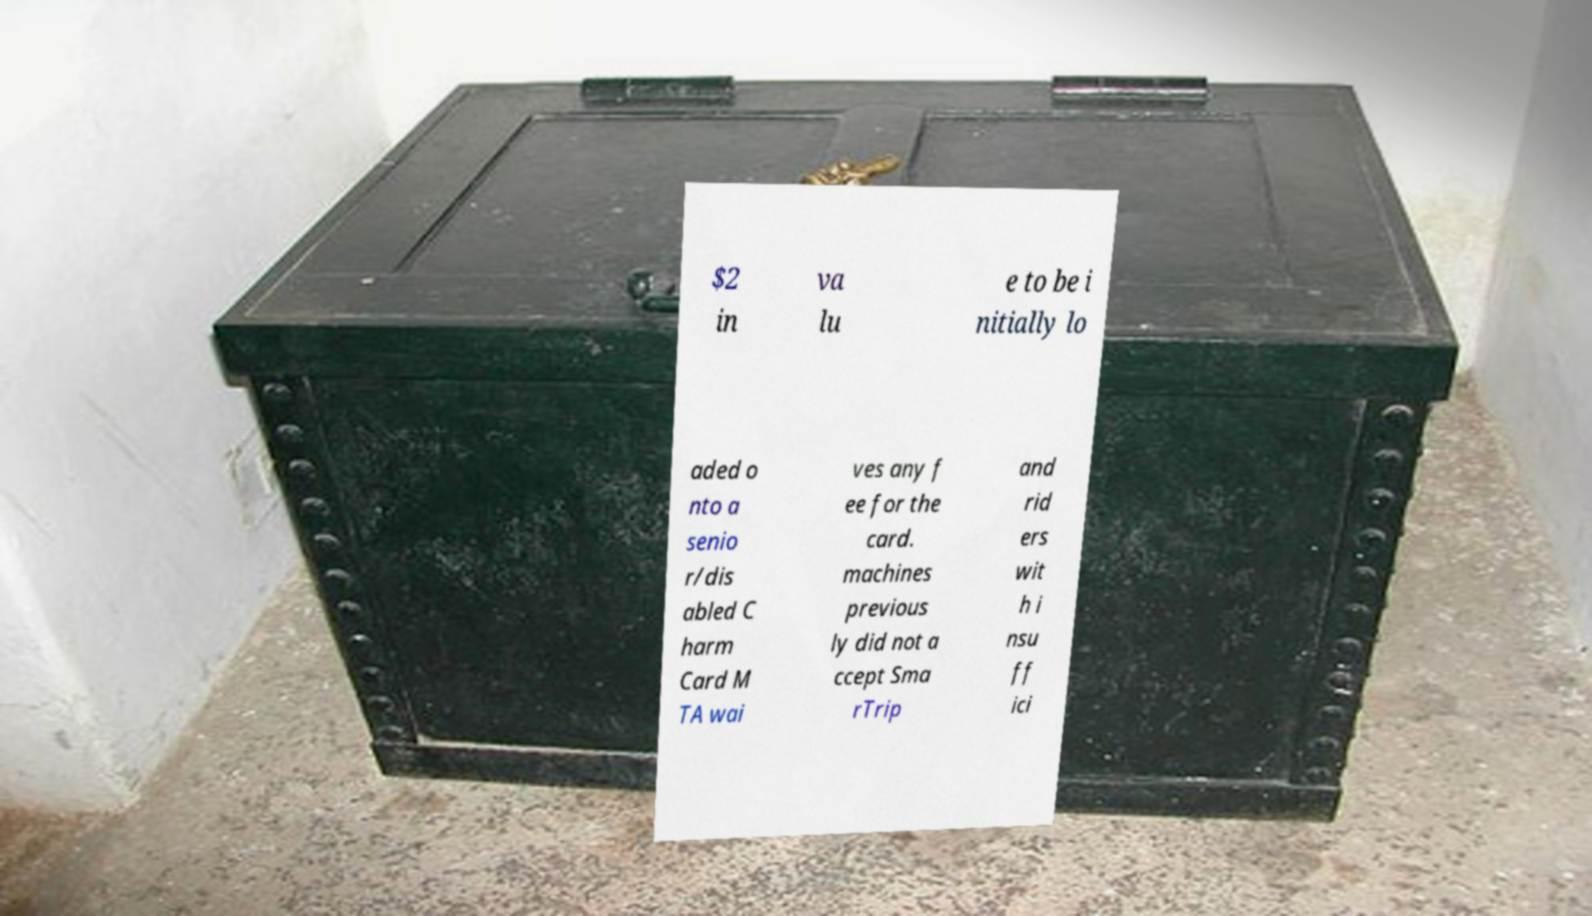Could you assist in decoding the text presented in this image and type it out clearly? $2 in va lu e to be i nitially lo aded o nto a senio r/dis abled C harm Card M TA wai ves any f ee for the card. machines previous ly did not a ccept Sma rTrip and rid ers wit h i nsu ff ici 